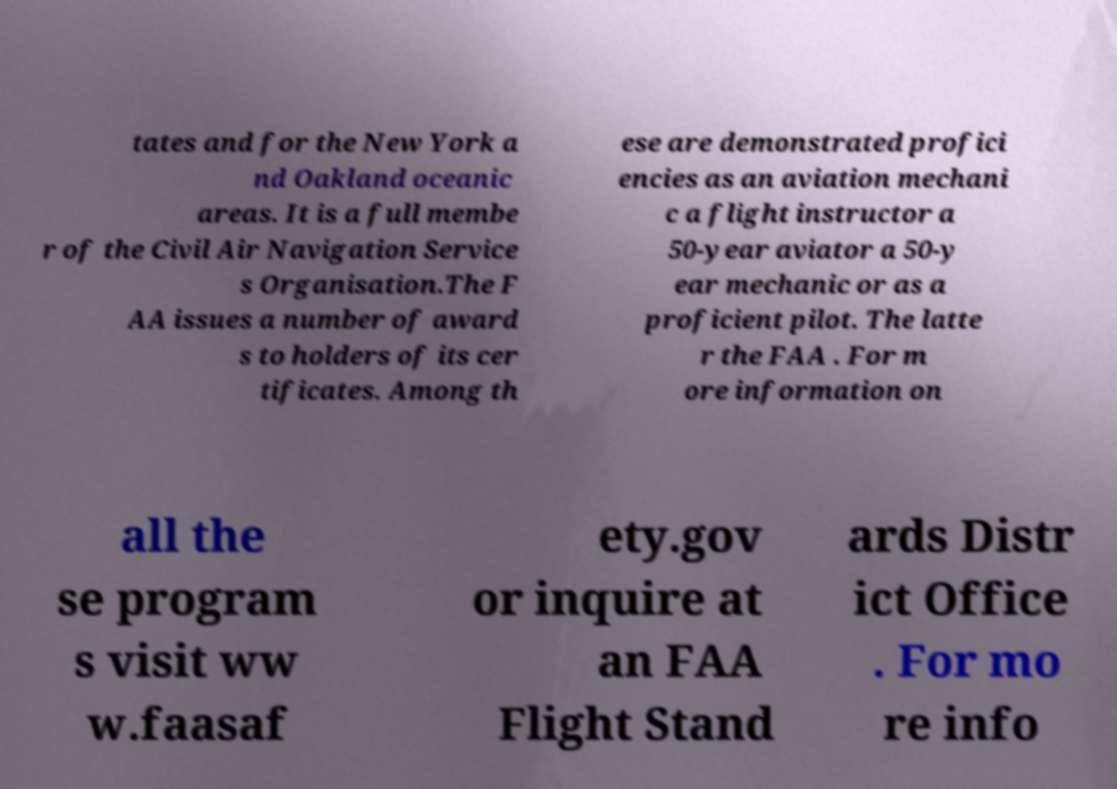Please identify and transcribe the text found in this image. tates and for the New York a nd Oakland oceanic areas. It is a full membe r of the Civil Air Navigation Service s Organisation.The F AA issues a number of award s to holders of its cer tificates. Among th ese are demonstrated profici encies as an aviation mechani c a flight instructor a 50-year aviator a 50-y ear mechanic or as a proficient pilot. The latte r the FAA . For m ore information on all the se program s visit ww w.faasaf ety.gov or inquire at an FAA Flight Stand ards Distr ict Office . For mo re info 